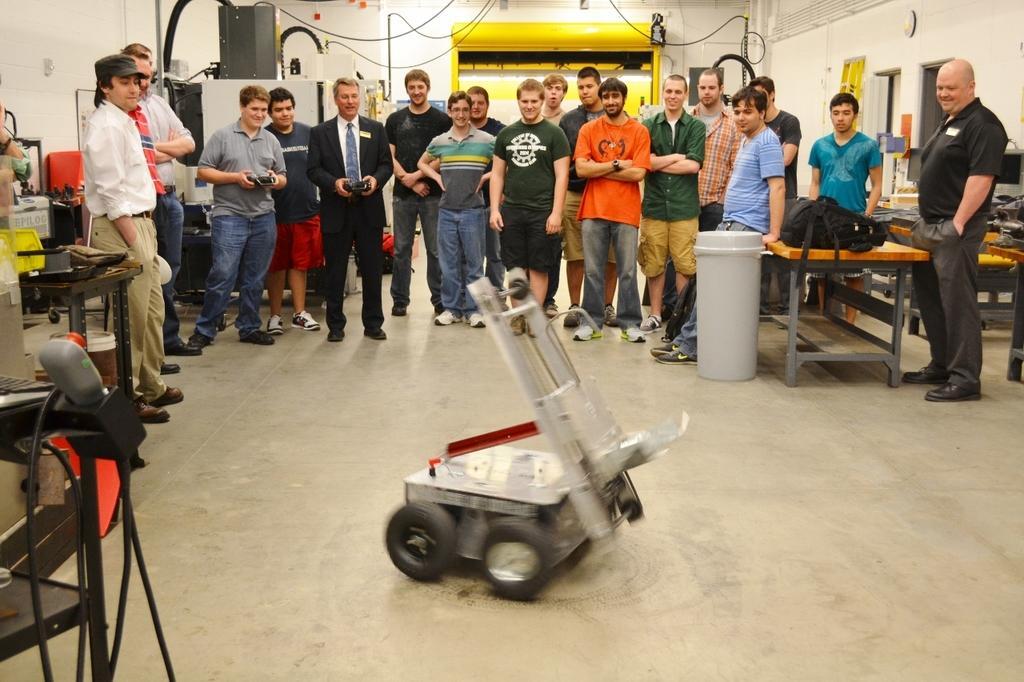Could you give a brief overview of what you see in this image? In this picture we can see the people standing. We can see the men are holding remotes. We can see few objects, tables, wires and boards. On the tables we can see a bag and few objects. We can see a vehicle on the floor. 